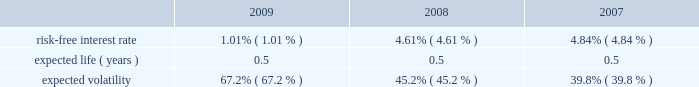Abiomed , inc .
And subsidiaries notes to consolidated financial statements 2014 ( continued ) note 12 .
Stock award plans and stock based compensation ( continued ) compensation expense recognized related to the company 2019s espp was approximately $ 0.1 million for each of the years ended march 31 , 2009 , 2008 and 2007 respectively .
The fair value of shares issued under the employee stock purchase plan was estimated on the commencement date of each offering period using the black-scholes option-pricing model with the following assumptions: .
Note 13 .
Capital stock in august 2008 , the company issued 2419932 shares of its common stock at a price of $ 17.3788 in a public offering , which resulted in net proceeds to the company of approximately $ 42.0 million , after deducting offering expenses .
In march 2007 , the company issued 5000000 shares of common stock in a public offering , and in april 2007 , an additional 80068 shares of common stock were issued in connection with the offering upon the partial exercise of the underwriters 2019 over-allotment option .
The company has authorized 1000000 shares of class b preferred stock , $ 0.01 par value , of which the board of directors can set the designation , rights and privileges .
No shares of class b preferred stock have been issued or are outstanding .
Note 14 .
Income taxes deferred tax assets and liabilities are recognized for the estimated future tax consequences attributable to tax benefit carryforwards and to differences between the financial statement amounts of assets and liabilities and their respective tax basis .
Deferred tax assets and liabilities are measured using enacted tax rates .
A valuation reserve is established if it is more likely than not that all or a portion of the deferred tax asset will not be realized .
The tax benefit associated with the stock option compensation deductions will be credited to equity when realized .
At march 31 , 2009 , the company had federal and state net operating loss carryforwards , or nols , of approximately $ 145.1 million and $ 97.1 million , respectively , which begin to expire in fiscal 2010 .
Additionally , at march 31 , 2009 , the company had federal and state research and development credit carryforwards of approximately $ 8.1 million and $ 4.2 million , respectively , which begin to expire in fiscal 2010 .
The company acquired impella , a german-based company , in may 2005 .
Impella had pre-acquisition net operating losses of approximately $ 18.2 million at the time of acquisition ( which is denominated in euros and is subject to foreign exchange remeasurement at each balance sheet date presented ) , and has since incurred net operating losses in each fiscal year since the acquisition .
During fiscal 2008 , the company determined that approximately $ 1.2 million of pre-acquisition operating losses could not be utilized .
The utilization of pre-acquisition net operating losses of impella in future periods is subject to certain statutory approvals and business requirements .
Due to uncertainties surrounding the company 2019s ability to generate future taxable income to realize these assets , a full valuation allowance has been established to offset the company 2019s net deferred tax assets and liabilities .
Additionally , the future utilization of the company 2019s nol and research and development credit carry forwards to offset future taxable income may be subject to a substantial annual limitation under section 382 of the internal revenue code due to ownership changes that have occurred previously or that could occur in the future .
Ownership changes , as defined in section 382 of the internal revenue code , can limit the amount of net operating loss carry forwards and research and development credit carry forwards that a company can use each year to offset future taxable income and taxes payable .
The company believes that all of its federal and state nol 2019s will be available for carryforward to future tax periods , subject to the statutory maximum carryforward limitation of any annual nol .
Any future potential limitation to all or a portion of the nol or research and development credit carry forwards , before they can be utilized , would reduce the company 2019s gross deferred tax assets .
The company will monitor subsequent ownership changes , which could impose limitations in the future. .
What percentage of impella's pre-acquisition net operating losses are expected to be utilized? 
Computations: ((18.2 - 1.2) / 18.2)
Answer: 0.93407. 